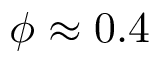Convert formula to latex. <formula><loc_0><loc_0><loc_500><loc_500>\phi \approx 0 . 4</formula> 